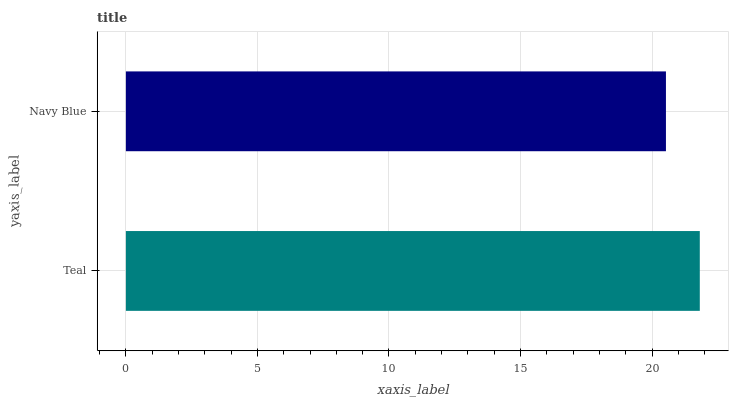Is Navy Blue the minimum?
Answer yes or no. Yes. Is Teal the maximum?
Answer yes or no. Yes. Is Navy Blue the maximum?
Answer yes or no. No. Is Teal greater than Navy Blue?
Answer yes or no. Yes. Is Navy Blue less than Teal?
Answer yes or no. Yes. Is Navy Blue greater than Teal?
Answer yes or no. No. Is Teal less than Navy Blue?
Answer yes or no. No. Is Teal the high median?
Answer yes or no. Yes. Is Navy Blue the low median?
Answer yes or no. Yes. Is Navy Blue the high median?
Answer yes or no. No. Is Teal the low median?
Answer yes or no. No. 